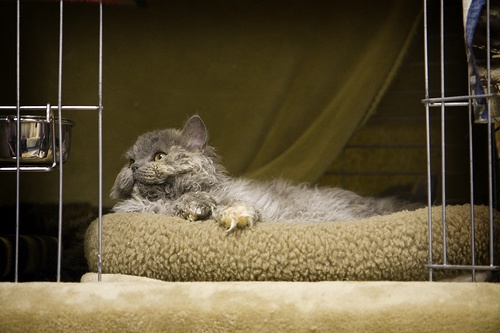Describe the objects in this image and their specific colors. I can see bed in black, tan, and olive tones, cat in black, darkgray, and gray tones, and bowl in black and gray tones in this image. 